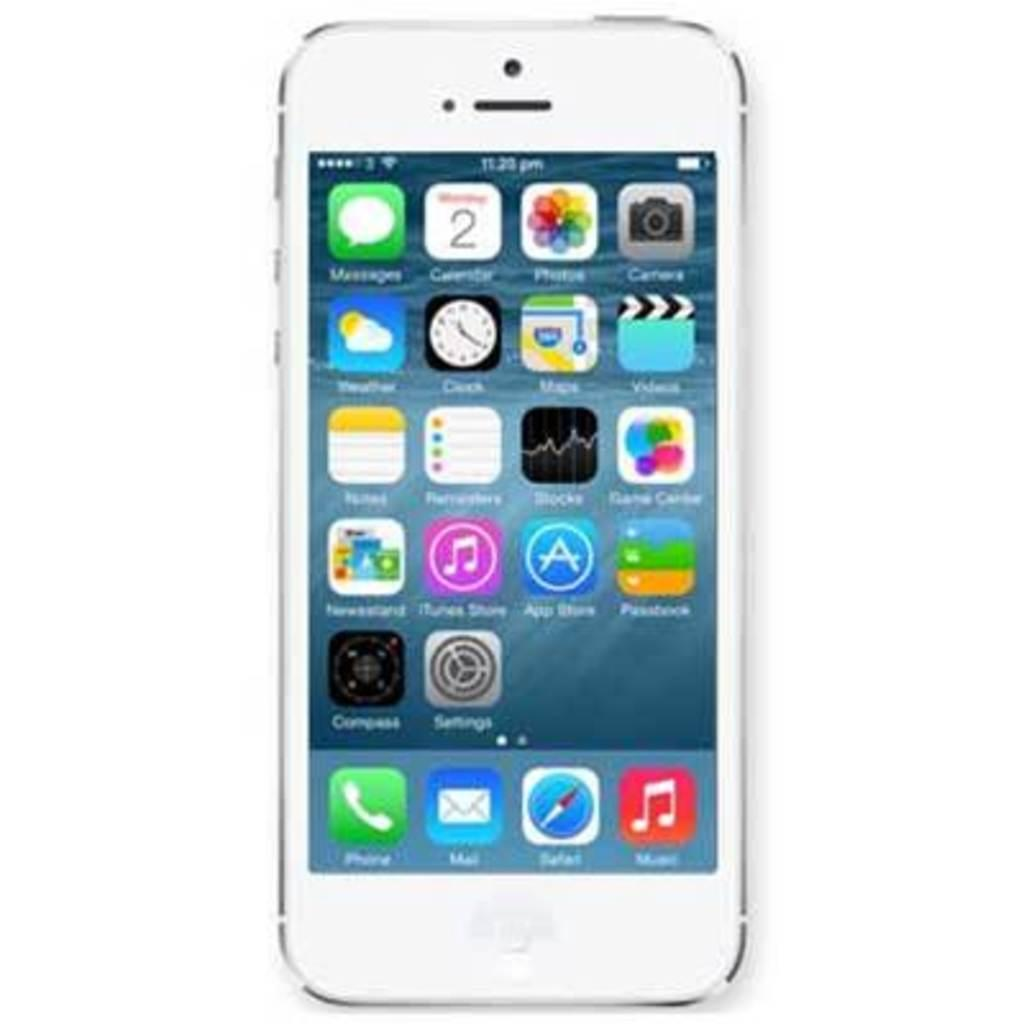What object is the main focus of the image? There is a mobile in the image. What is displayed on the mobile? The mobile contains pictures and text. What is the color of the background in the image? The background of the image is white. How many clovers are visible on the mobile in the image? There is no mention of clovers in the image, so it is impossible to determine their presence or quantity. 